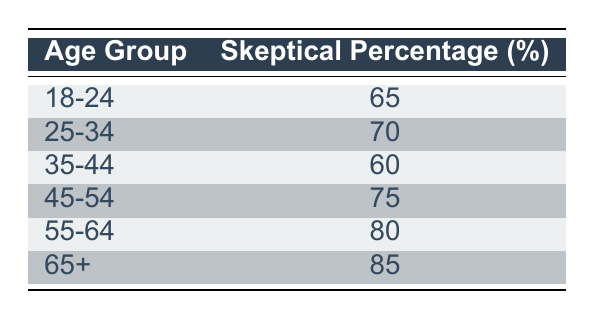What percentage of the 18-24 age group expressed skepticism towards alternative medicine? The table shows that the skeptical percentage for the 18-24 age group is 65%.
Answer: 65% Which age group has the highest percentage of skepticism? According to the table, the 65+ age group has the highest skeptical percentage, which is 85%.
Answer: 85% What is the difference in skeptical percentages between the 45-54 and 55-64 age groups? From the table, the skeptical percentage for the 45-54 age group is 75%, and for the 55-64 age group, it is 80%. The difference is 80% - 75% = 5%.
Answer: 5% Is the skeptical percentage for the 35-44 age group higher than that for the 18-24 age group? The skeptical percentage for the 35-44 age group is 60% while for the 18-24 age group it is 65%. Therefore, the statement is false.
Answer: No What is the average skeptical percentage of all age groups listed in the table? First, we sum the skeptical percentages: 65 + 70 + 60 + 75 + 80 + 85 = 435. There are 6 age groups, so we divide the total by 6: 435 / 6 = 72.5.
Answer: 72.5 How many age groups have a skeptical percentage of 75% or higher? Looking at the table, the age groups with 75% or higher are 45-54, 55-64, and 65+, totaling 3 age groups.
Answer: 3 What is the skeptical percentage for the 25-34 age group and how does it compare to that of the 35-44 age group? The skeptical percentage for the 25-34 age group is 70% and for the 35-44 age group it is 60%. The 25-34 age group is 10% higher than the 35-44 age group.
Answer: 10% Do more than 50% of the participants in the 55-64 age group express skepticism? The skeptical percentage for the 55-64 age group is 80%, which is greater than 50%. Thus, the statement is true.
Answer: Yes What age group has the second highest skeptical percentage? The table indicates that the second highest skeptical percentage is for the 55-64 age group at 80%.
Answer: 80% 